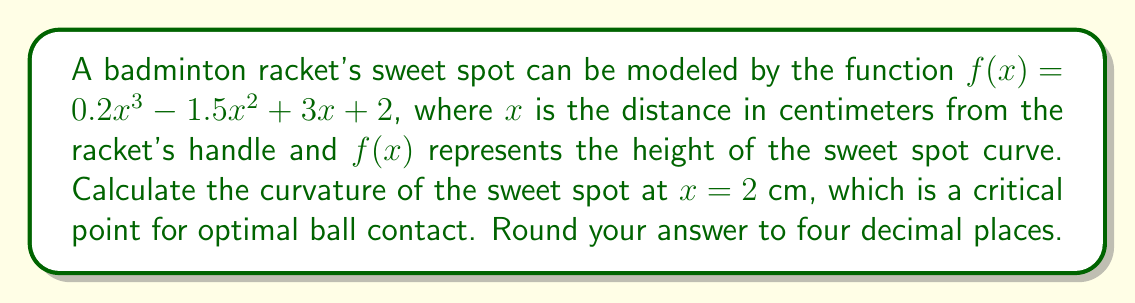Teach me how to tackle this problem. To find the curvature of the sweet spot at $x = 2$ cm, we'll use the curvature formula:

$$\kappa = \frac{|f''(x)|}{(1 + [f'(x)]^2)^{3/2}}$$

Step 1: Find $f'(x)$ and $f''(x)$
$f'(x) = 0.6x^2 - 3x + 3$
$f''(x) = 1.2x - 3$

Step 2: Calculate $f'(2)$ and $f''(2)$
$f'(2) = 0.6(2)^2 - 3(2) + 3 = 2.4 - 6 + 3 = -0.6$
$f''(2) = 1.2(2) - 3 = 2.4 - 3 = -0.6$

Step 3: Substitute values into the curvature formula
$$\kappa = \frac{|-0.6|}{(1 + [-0.6]^2)^{3/2}}$$

Step 4: Simplify and calculate
$$\kappa = \frac{0.6}{(1 + 0.36)^{3/2}} = \frac{0.6}{1.36^{3/2}} \approx 0.3793$$

Step 5: Round to four decimal places
$\kappa \approx 0.3793$
Answer: 0.3793 